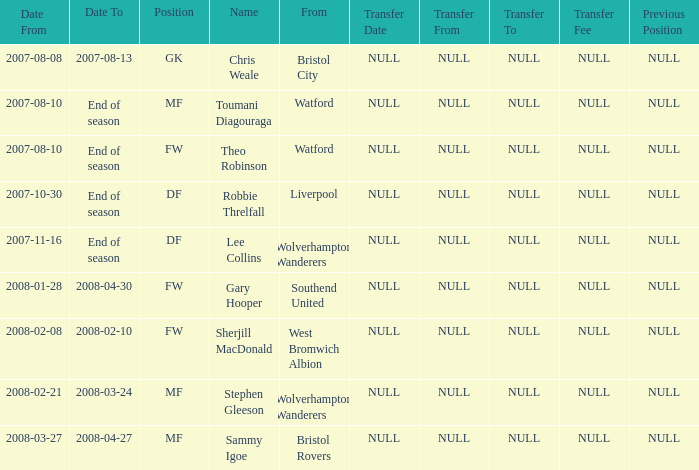What was the starting date for theo robinson, who remained on the team until the season's conclusion? 2007-08-10. 